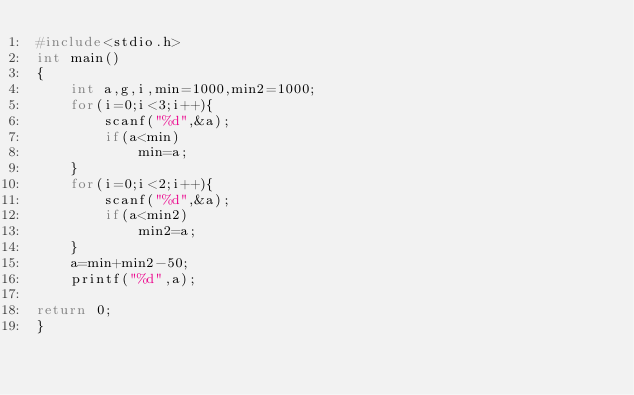<code> <loc_0><loc_0><loc_500><loc_500><_C_>#include<stdio.h>
int main()
{
	int a,g,i,min=1000,min2=1000;
	for(i=0;i<3;i++){
		scanf("%d",&a);
		if(a<min)
			min=a;
	}
	for(i=0;i<2;i++){
		scanf("%d",&a);
		if(a<min2)
			min2=a;
	}
	a=min+min2-50;
	printf("%d",a);

return 0;
}</code> 